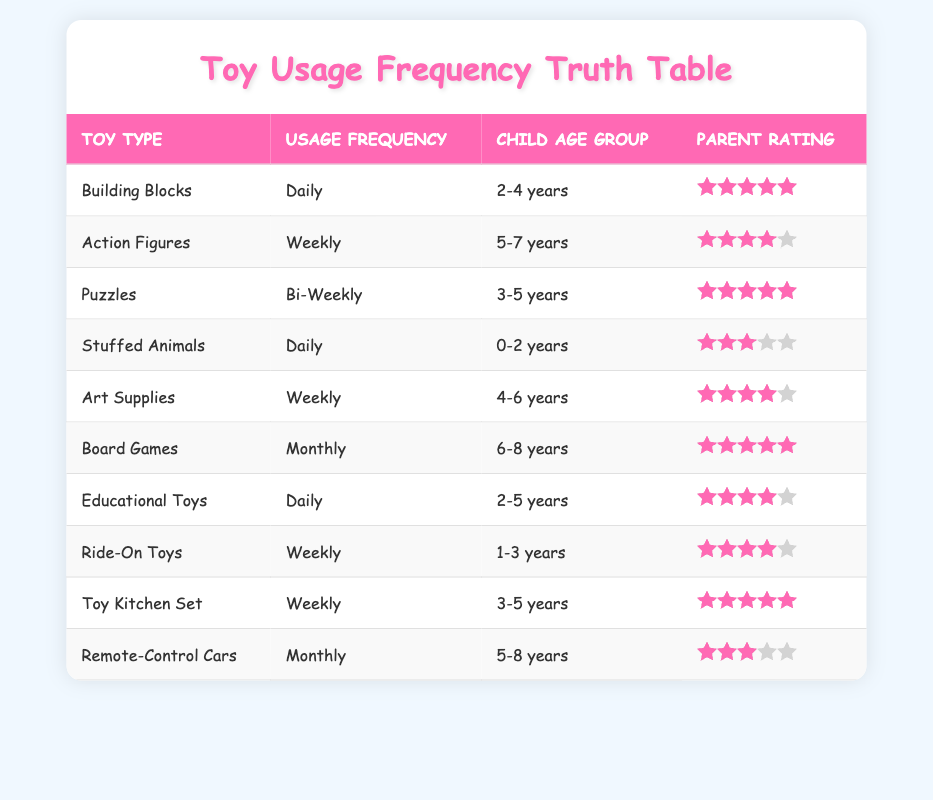What toy type is used daily by children? To find the toy types that are used daily, I look for the rows where the usage frequency is "Daily." There are three toys listed under this frequency: Building Blocks, Stuffed Animals, and Educational Toys.
Answer: Building Blocks, Stuffed Animals, Educational Toys What is the average parent rating for toys used weekly? First, I identify the toys that are used weekly, which are Action Figures, Art Supplies, Ride-On Toys, and Toy Kitchen Set. Then I calculate the total rating: (4 + 4 + 4 + 5) = 17. There are four toys, so the average is 17/4 = 4.25.
Answer: 4.25 Are there any toys rated 5 that are used monthly? I check the toy list for those labeled with a usage frequency of "Monthly." The two toys are Board Games and Remote-Control Cars, with ratings of 5 and 3 respectively. Since only Board Games has a rating of 5, the answer is yes, there is one toy.
Answer: Yes How many toys rated 4 are in the age group of 4-6 years? I review the table to find toys used by children aged 4-6 years and their ratings. The toys in this age group are Art Supplies and Toy Kitchen Set, both rated 4. So, there are two toys rated 4 for this age group.
Answer: 2 What is the total number of toys listed for children aged 3-5 years? I examine the table for the age group of 3-5 years, which includes three toys: Puzzles, Toy Kitchen Set, and Educational Toys. By counting these entries, I find there are three toys in this age category.
Answer: 3 How many toys are rated below 4? I will look through the ratings for each toy. The toys with ratings below 4 are Stuffed Animals (3) and Remote-Control Cars (3). In total, there are two toys rated below 4.
Answer: 2 Is there a toy used daily that is designed for children aged 0-2 years? I check the daily usage toys and their respective age groups. Stuffed Animals is the only daily toy for the age group of 0-2 years, which confirms this toy meets the criteria.
Answer: Yes What is the difference in ratings between the highest rated toy and the lowest rated toy overall? First, I identify the ratings: the highest rating is 5 (Board Games, Building Blocks, Puzzles, and Toy Kitchen Set) and the lowest rating is 3 (Stuffed Animals and Remote-Control Cars). The difference is 5 - 3 = 2.
Answer: 2 